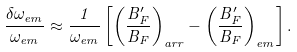Convert formula to latex. <formula><loc_0><loc_0><loc_500><loc_500>\frac { \delta \omega _ { e m } } { \omega _ { e m } } \approx \frac { 1 } { \omega _ { e m } } \left [ \left ( \frac { B _ { F } ^ { \prime } } { B _ { F } } \right ) _ { a r r } - \left ( \frac { B _ { F } ^ { \prime } } { B _ { F } } \right ) _ { e m } \right ] .</formula> 